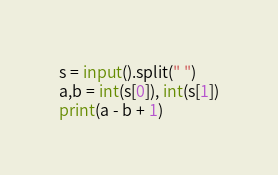<code> <loc_0><loc_0><loc_500><loc_500><_Python_>s = input().split(" ")
a,b = int(s[0]), int(s[1])
print(a - b + 1)</code> 